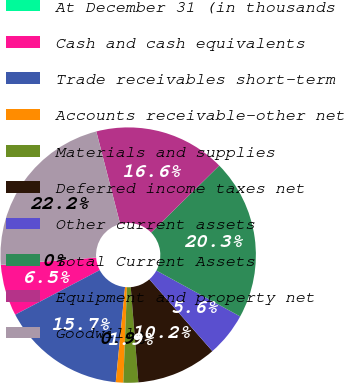<chart> <loc_0><loc_0><loc_500><loc_500><pie_chart><fcel>At December 31 (in thousands<fcel>Cash and cash equivalents<fcel>Trade receivables short-term<fcel>Accounts receivable-other net<fcel>Materials and supplies<fcel>Deferred income taxes net<fcel>Other current assets<fcel>Total Current Assets<fcel>Equipment and property net<fcel>Goodwill<nl><fcel>0.03%<fcel>6.49%<fcel>15.72%<fcel>0.95%<fcel>1.88%<fcel>10.18%<fcel>5.57%<fcel>20.34%<fcel>16.65%<fcel>22.19%<nl></chart> 